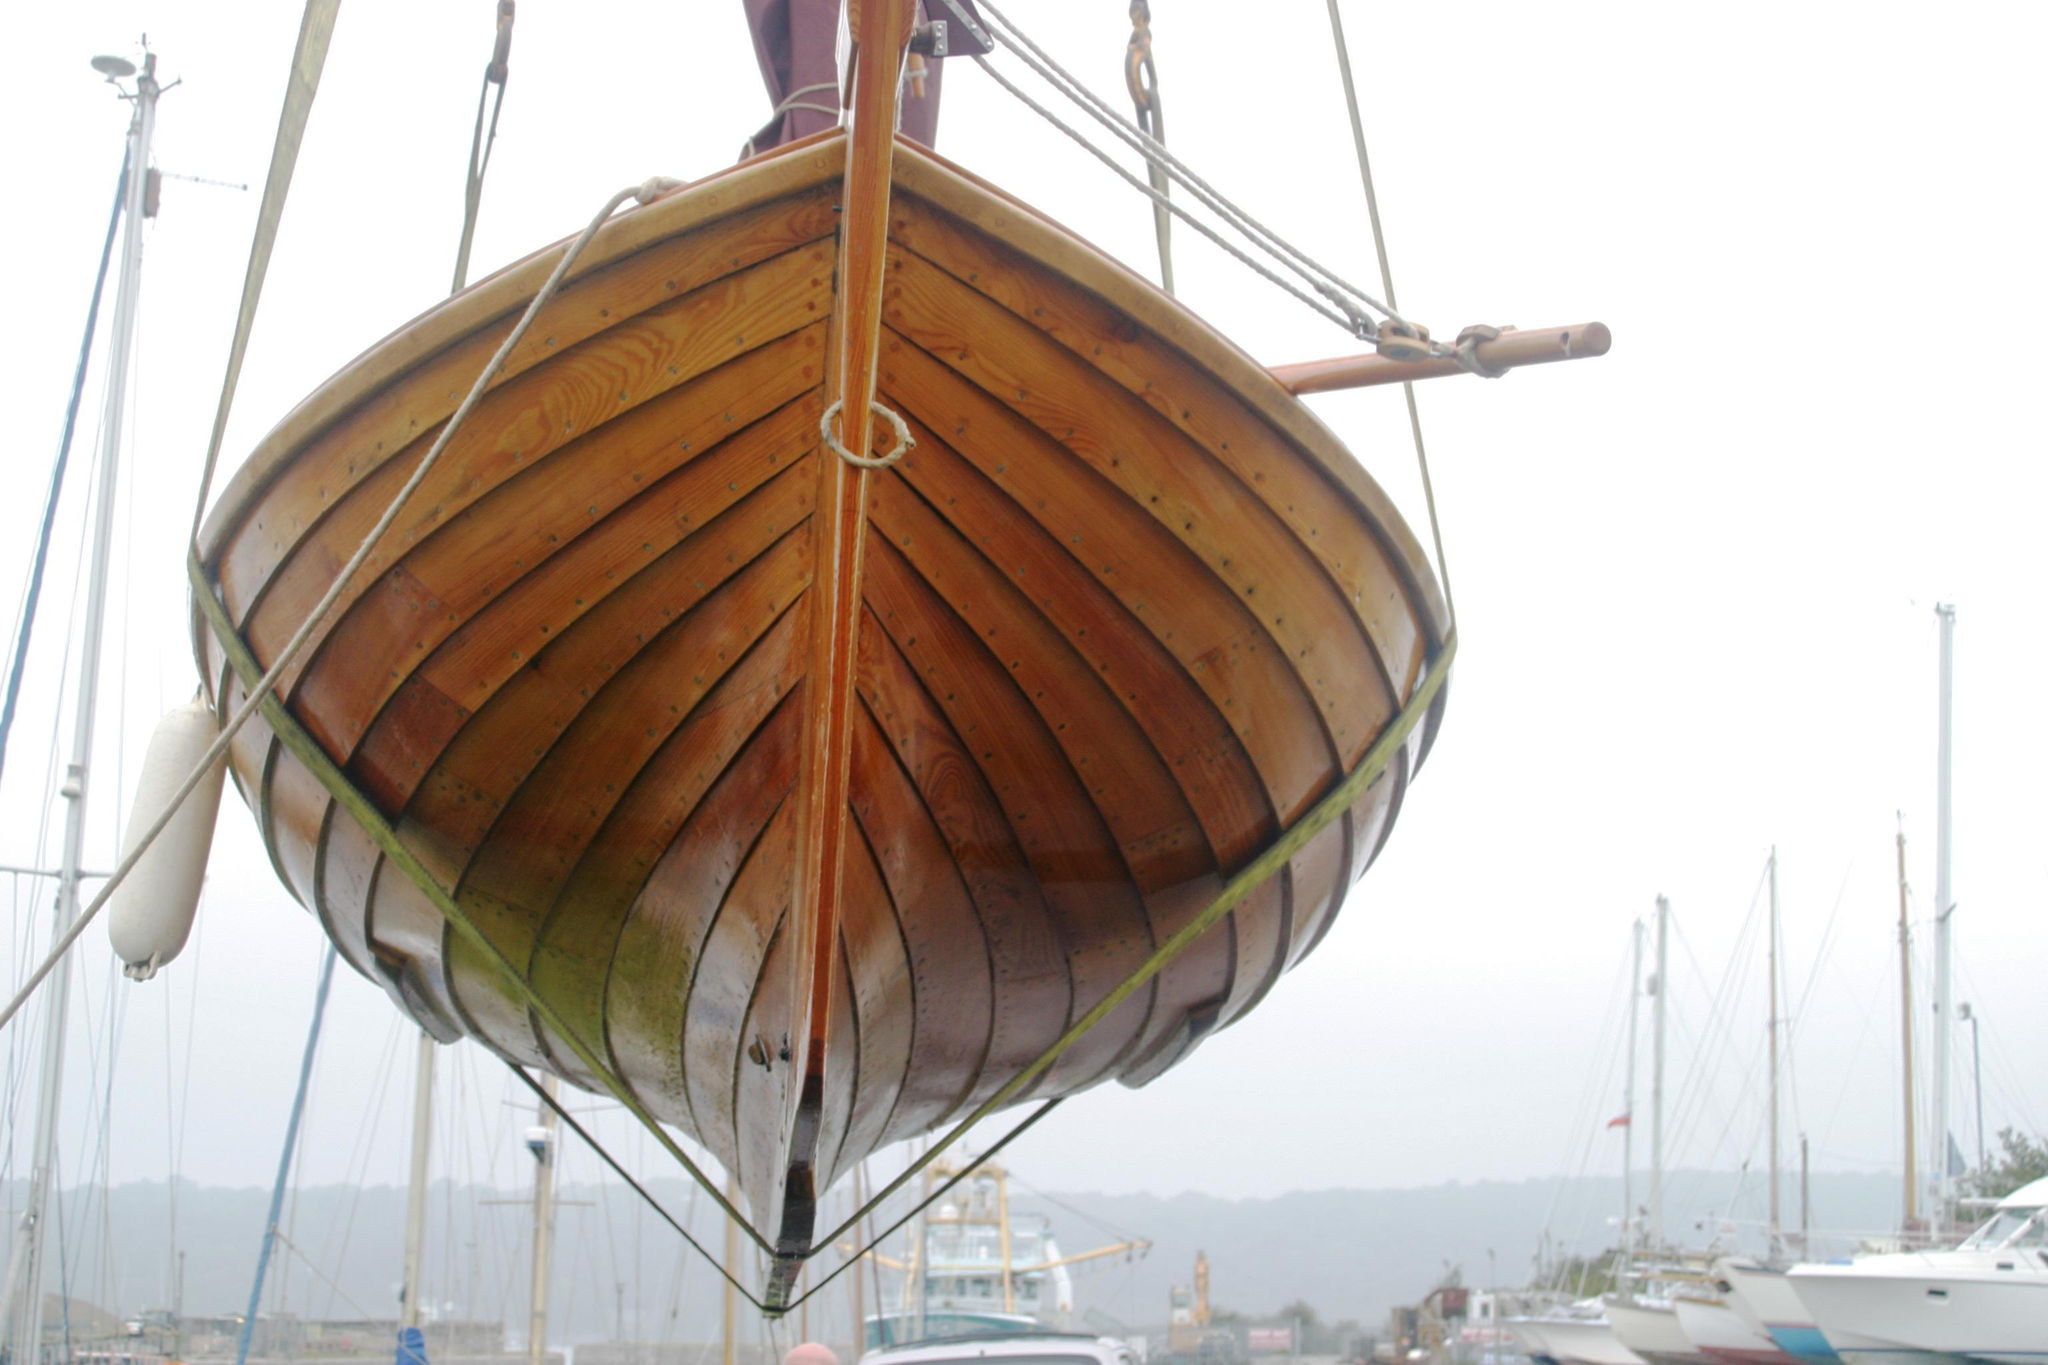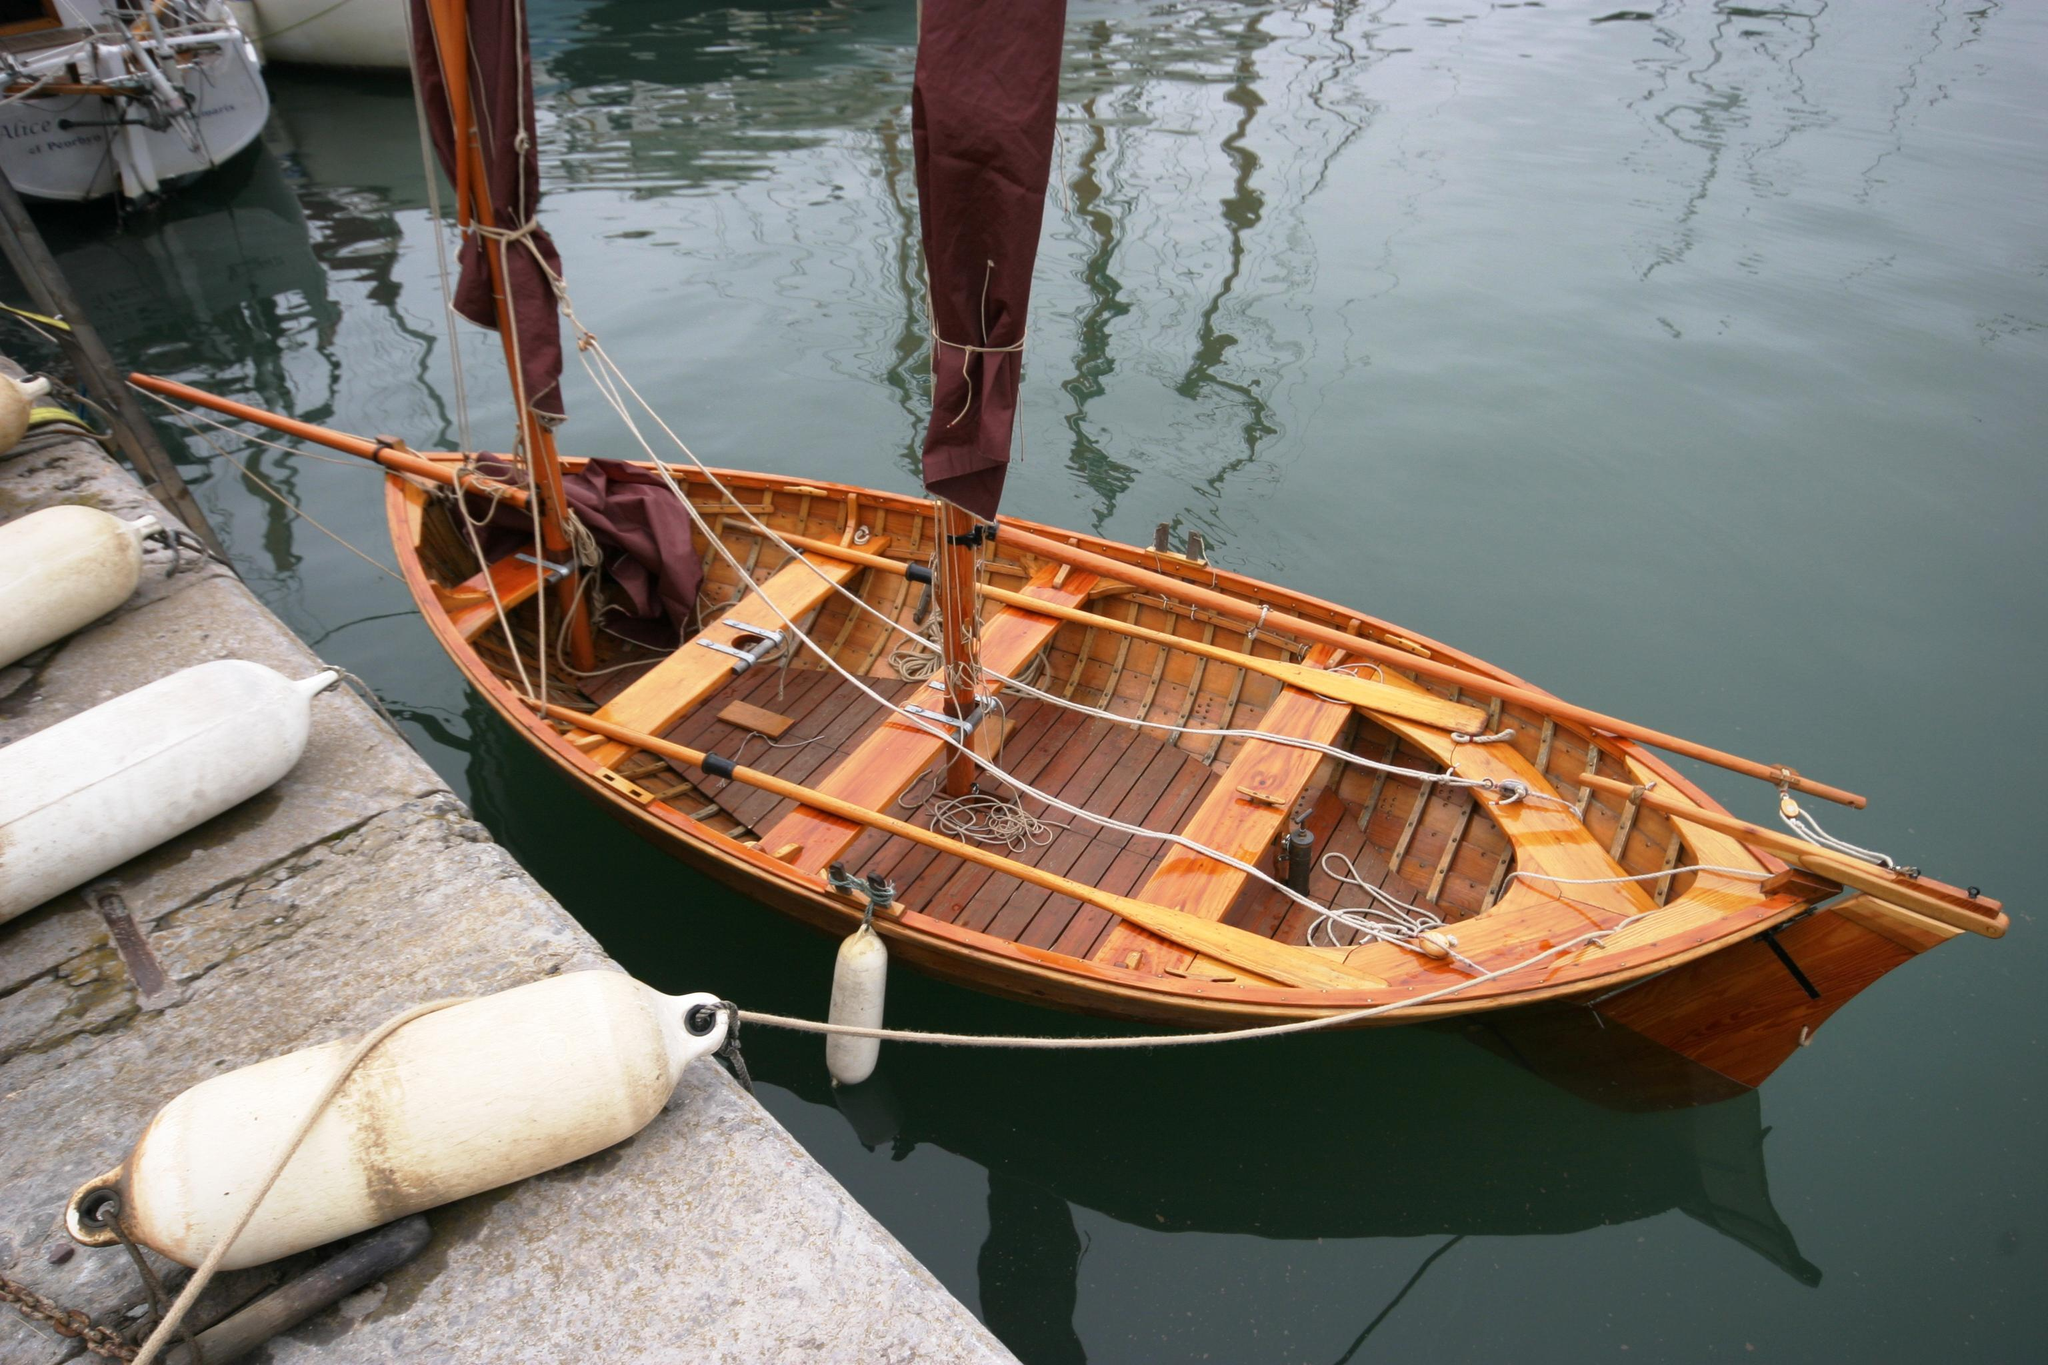The first image is the image on the left, the second image is the image on the right. Evaluate the accuracy of this statement regarding the images: "There is at least three humans riding in a sailboat.". Is it true? Answer yes or no. No. The first image is the image on the left, the second image is the image on the right. Analyze the images presented: Is the assertion "At least three people sit in boats with red sails." valid? Answer yes or no. No. 